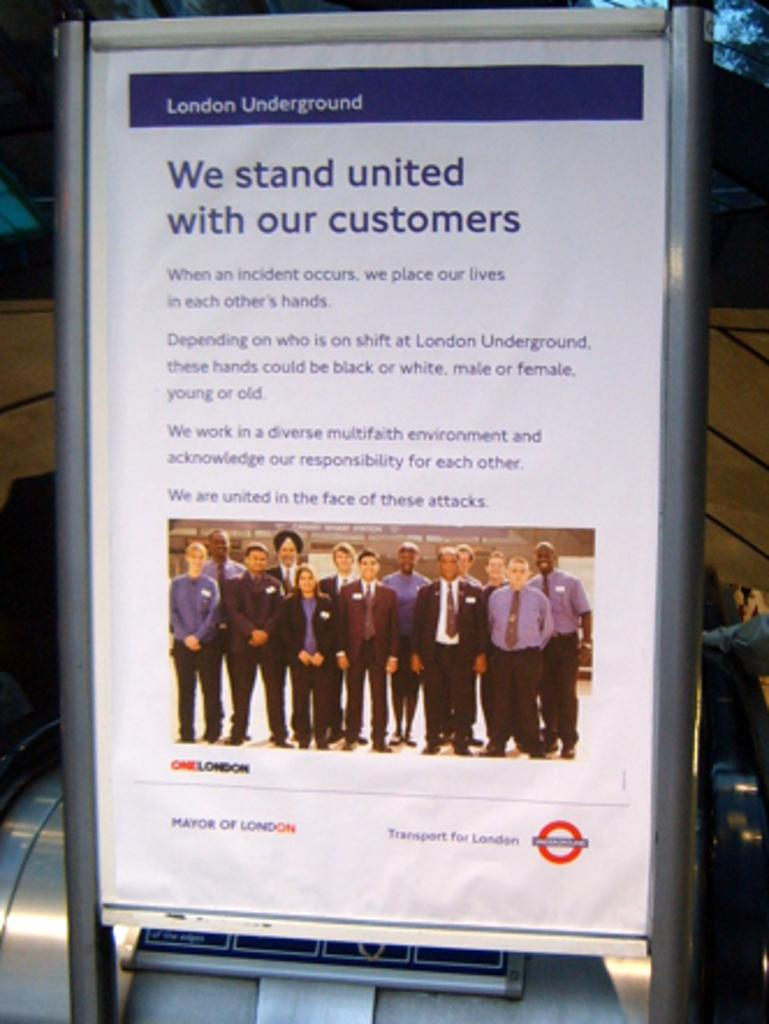<image>
Write a terse but informative summary of the picture. A poster from the London Underground about being united with their customers. 